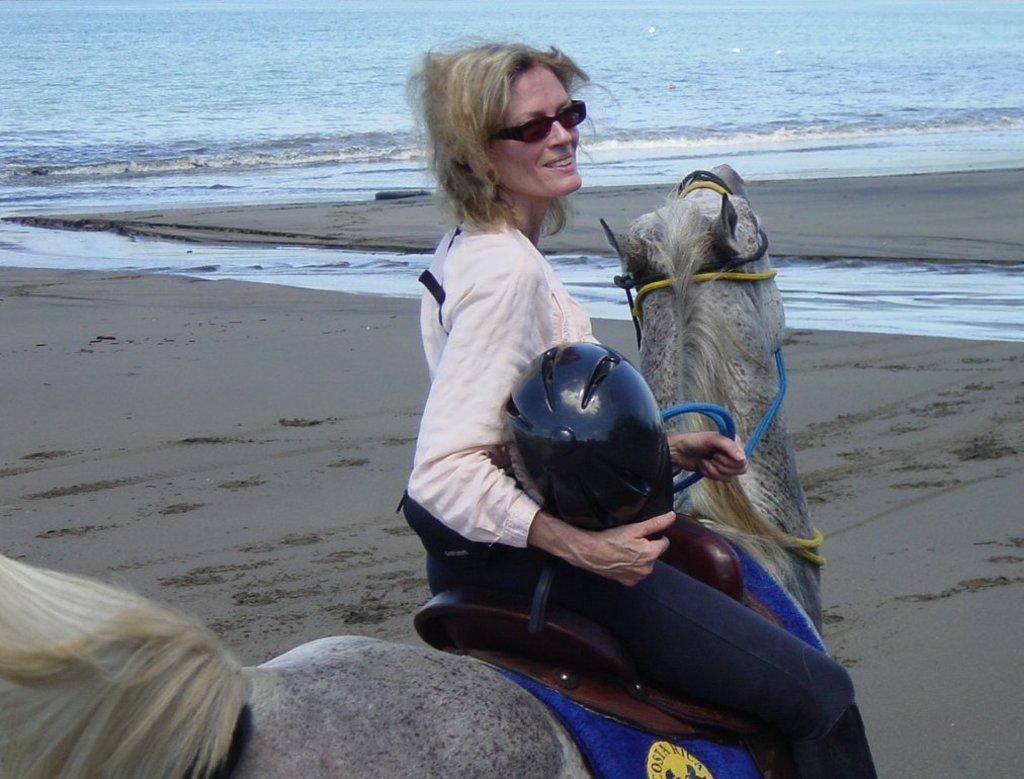What is the main subject of the subject of the image? There is a person in the image. What is the person doing in the image? The person is sitting on a horse. What objects is the person holding in the image? The person is holding a helmet and a thread. What type of terrain can be seen in the image? There is sand and water visible in the image. What type of oatmeal is being served on the bed in the image? There is no oatmeal or bed present in the image; it features a person sitting on a horse. Can you describe the seashore depicted in the image? There is no seashore depicted in the image; it shows a person sitting on a horse in a sandy and watery environment. 